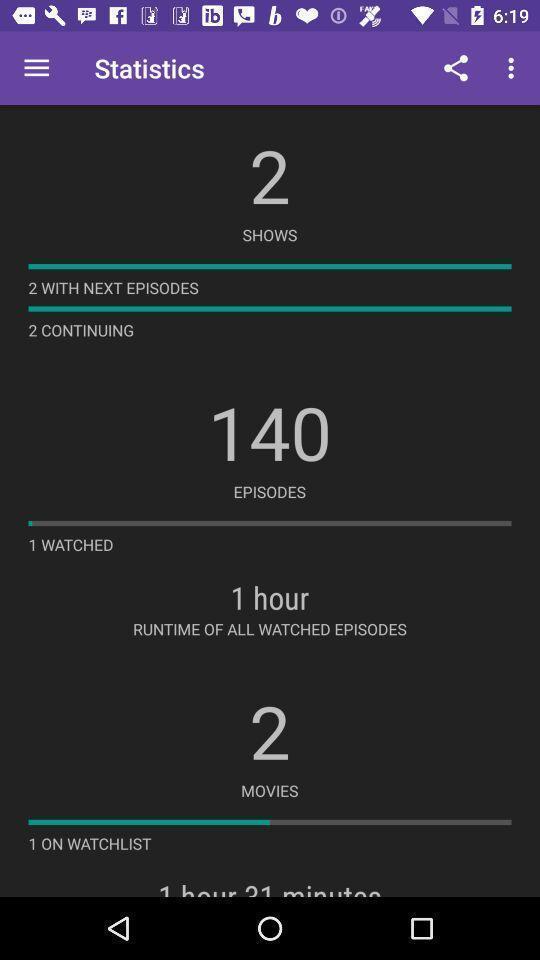Describe the content in this image. Statistics page with list of shows movies and episodes. 